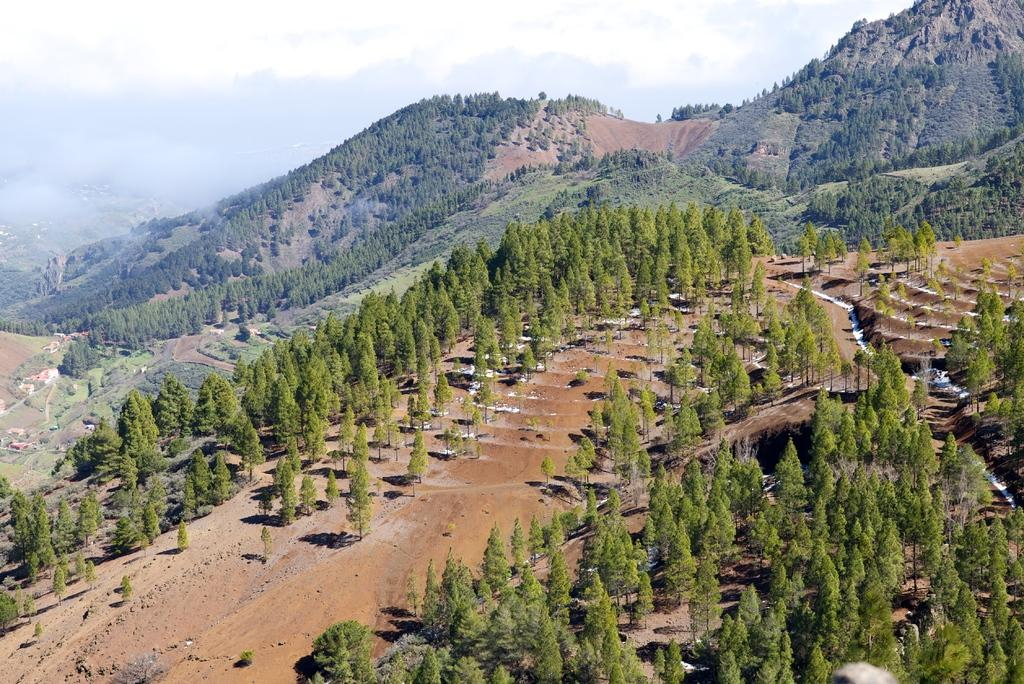What type of natural landform can be seen in the image? There are mountains in the image. What type of vegetation is present in the image? There are many trees in the image. What type of lace can be seen on the tongue of the mountain in the image? There is no lace present in the image, nor is there any indication of a tongue on the mountain. 